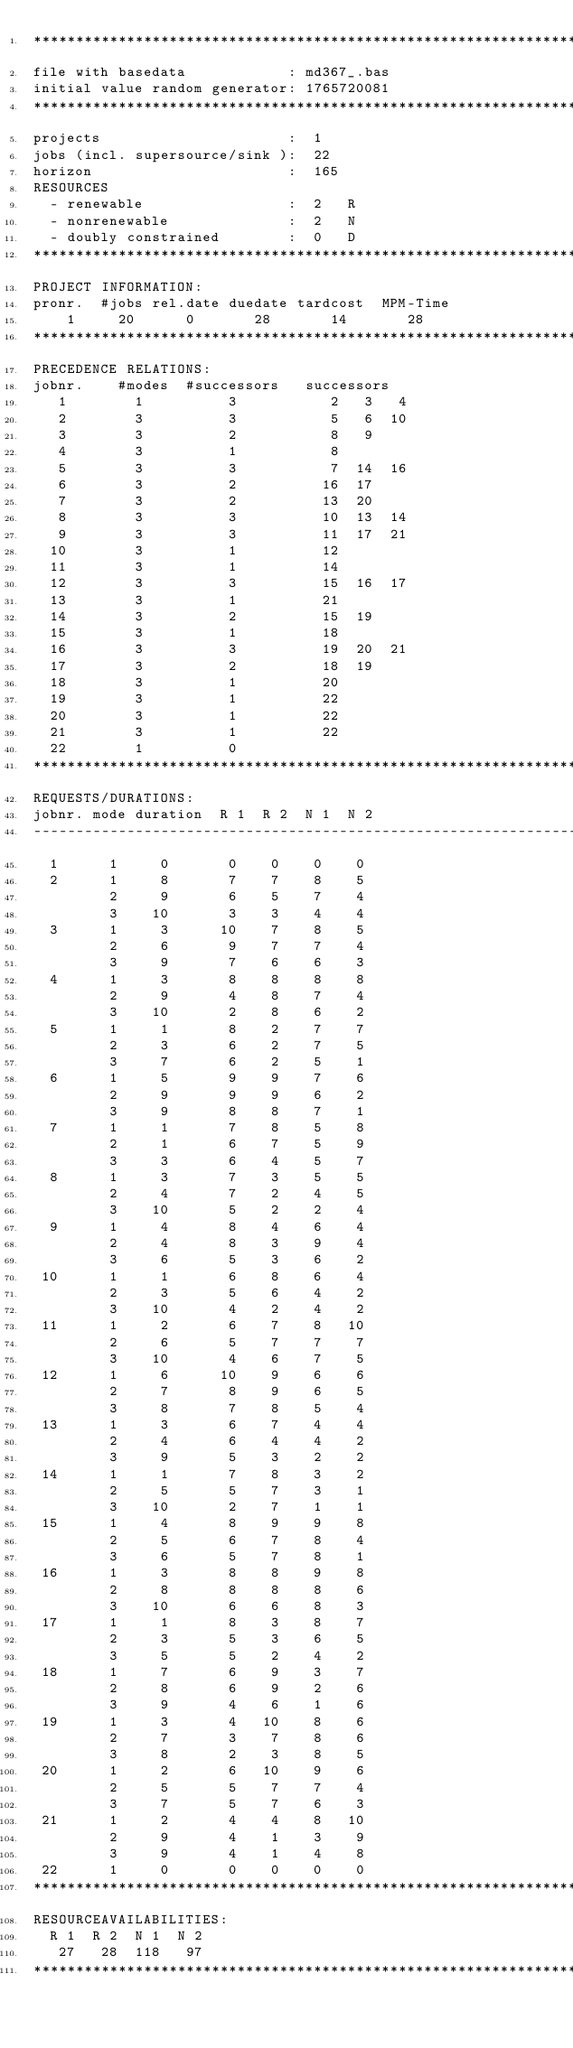<code> <loc_0><loc_0><loc_500><loc_500><_ObjectiveC_>************************************************************************
file with basedata            : md367_.bas
initial value random generator: 1765720081
************************************************************************
projects                      :  1
jobs (incl. supersource/sink ):  22
horizon                       :  165
RESOURCES
  - renewable                 :  2   R
  - nonrenewable              :  2   N
  - doubly constrained        :  0   D
************************************************************************
PROJECT INFORMATION:
pronr.  #jobs rel.date duedate tardcost  MPM-Time
    1     20      0       28       14       28
************************************************************************
PRECEDENCE RELATIONS:
jobnr.    #modes  #successors   successors
   1        1          3           2   3   4
   2        3          3           5   6  10
   3        3          2           8   9
   4        3          1           8
   5        3          3           7  14  16
   6        3          2          16  17
   7        3          2          13  20
   8        3          3          10  13  14
   9        3          3          11  17  21
  10        3          1          12
  11        3          1          14
  12        3          3          15  16  17
  13        3          1          21
  14        3          2          15  19
  15        3          1          18
  16        3          3          19  20  21
  17        3          2          18  19
  18        3          1          20
  19        3          1          22
  20        3          1          22
  21        3          1          22
  22        1          0        
************************************************************************
REQUESTS/DURATIONS:
jobnr. mode duration  R 1  R 2  N 1  N 2
------------------------------------------------------------------------
  1      1     0       0    0    0    0
  2      1     8       7    7    8    5
         2     9       6    5    7    4
         3    10       3    3    4    4
  3      1     3      10    7    8    5
         2     6       9    7    7    4
         3     9       7    6    6    3
  4      1     3       8    8    8    8
         2     9       4    8    7    4
         3    10       2    8    6    2
  5      1     1       8    2    7    7
         2     3       6    2    7    5
         3     7       6    2    5    1
  6      1     5       9    9    7    6
         2     9       9    9    6    2
         3     9       8    8    7    1
  7      1     1       7    8    5    8
         2     1       6    7    5    9
         3     3       6    4    5    7
  8      1     3       7    3    5    5
         2     4       7    2    4    5
         3    10       5    2    2    4
  9      1     4       8    4    6    4
         2     4       8    3    9    4
         3     6       5    3    6    2
 10      1     1       6    8    6    4
         2     3       5    6    4    2
         3    10       4    2    4    2
 11      1     2       6    7    8   10
         2     6       5    7    7    7
         3    10       4    6    7    5
 12      1     6      10    9    6    6
         2     7       8    9    6    5
         3     8       7    8    5    4
 13      1     3       6    7    4    4
         2     4       6    4    4    2
         3     9       5    3    2    2
 14      1     1       7    8    3    2
         2     5       5    7    3    1
         3    10       2    7    1    1
 15      1     4       8    9    9    8
         2     5       6    7    8    4
         3     6       5    7    8    1
 16      1     3       8    8    9    8
         2     8       8    8    8    6
         3    10       6    6    8    3
 17      1     1       8    3    8    7
         2     3       5    3    6    5
         3     5       5    2    4    2
 18      1     7       6    9    3    7
         2     8       6    9    2    6
         3     9       4    6    1    6
 19      1     3       4   10    8    6
         2     7       3    7    8    6
         3     8       2    3    8    5
 20      1     2       6   10    9    6
         2     5       5    7    7    4
         3     7       5    7    6    3
 21      1     2       4    4    8   10
         2     9       4    1    3    9
         3     9       4    1    4    8
 22      1     0       0    0    0    0
************************************************************************
RESOURCEAVAILABILITIES:
  R 1  R 2  N 1  N 2
   27   28  118   97
************************************************************************
</code> 